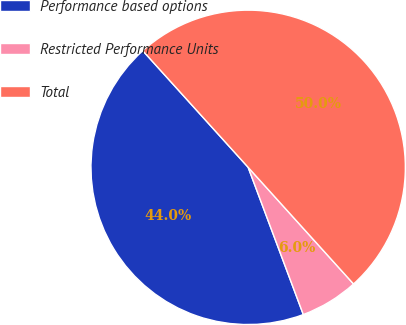<chart> <loc_0><loc_0><loc_500><loc_500><pie_chart><fcel>Performance based options<fcel>Restricted Performance Units<fcel>Total<nl><fcel>44.01%<fcel>5.99%<fcel>50.0%<nl></chart> 